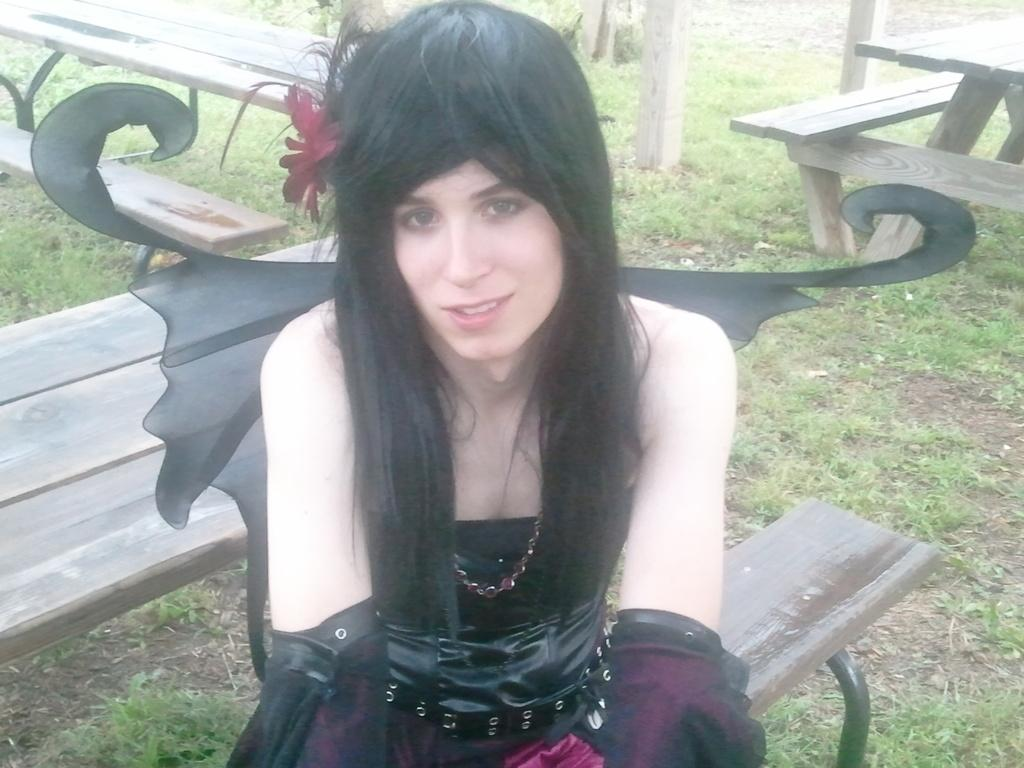What is the woman in the image doing? The woman is sitting on a bench in the image. What colors are the woman's clothes? The woman is wearing black and pink clothes. What type of plant can be seen in the image? There is a flower in the image. What type of terrain is visible in the image? There is grass in the image. What structure is present in the image? There is a pole in the image. How many children are playing with the wheel in the image? There is no wheel or children present in the image. What type of leaf can be seen falling from the tree in the image? There is no tree or leaf present in the image. 